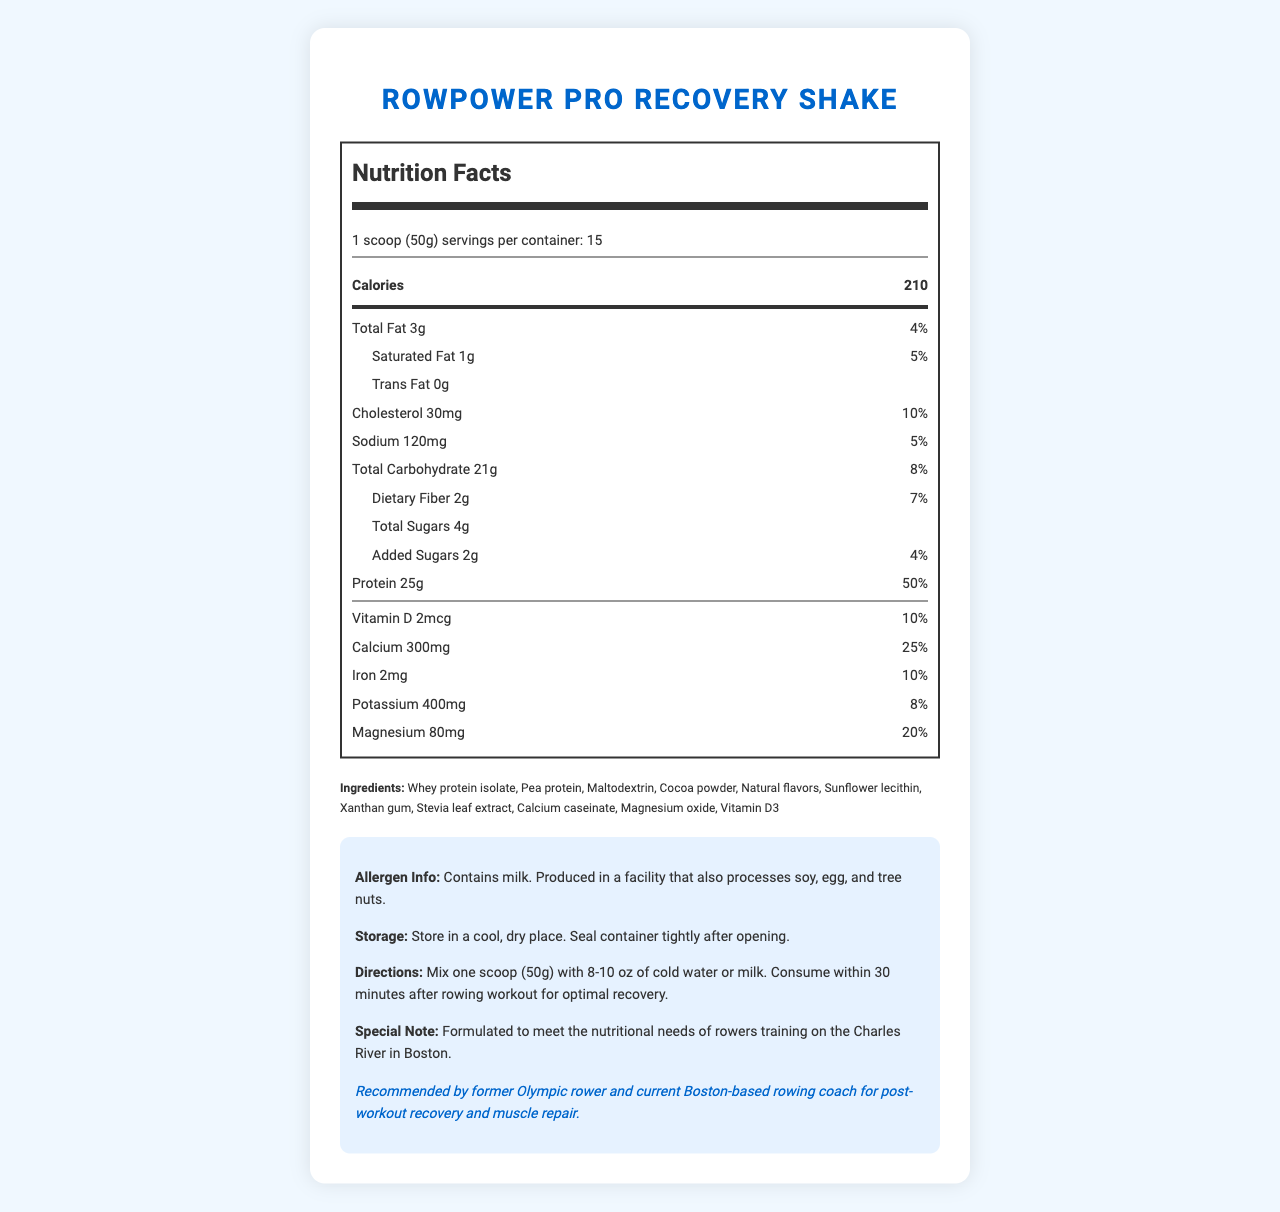Who is the product "RowPower Pro Recovery Shake" recommended by? The coach endorsement section mentions that the product is recommended by a former Olympic rower and current Boston-based rowing coach.
Answer: A former Olympic rower and current Boston-based rowing coach How many calories are there per serving of RowPower Pro Recovery Shake? The nutrition label clearly states that there are 210 calories per serving.
Answer: 210 What is the serving size for this product? The serving size is listed as 1 scoop (50g) in the document.
Answer: 1 scoop (50g) How many servings are there per container? The document specifies that there are 15 servings per container.
Answer: 15 What type of fat content does this product have? The nutrition facts list total fat as 3g, saturated fat as 1g, and trans fat as 0g.
Answer: 3g total fat, 1g saturated fat, 0g trans fat What percentage of the daily value of protein does one serving provide? The document states that one serving provides 25g of protein, which is 50% of the daily value.
Answer: 50% Which vitamin and mineral provides the highest percentage of daily value? A. Vitamin D B. Calcium C. Iron D. Potassium E. Magnesium The document lists calcium as providing 25% of the daily value, which is higher than other listed vitamins and minerals.
Answer: B. Calcium How should one consume RowPower Pro Recovery Shake for optimal recovery? A. Mix one scoop with 16 oz of water before a meal B. Mix one scoop with 8-10 oz of cold water or milk and consume within 30 minutes after a rowing workout C. Mix one scoop with 8-10 oz of warm milk before bedtime The directions section advises users to mix one scoop with 8-10 oz of cold water or milk and consume it within 30 minutes after a rowing workout for optimal recovery.
Answer: B. Mix one scoop with 8-10 oz of cold water or milk and consume within 30 minutes after a rowing workout Is the product safe for someone who is allergic to milk? The allergen information states that the product contains milk.
Answer: No Does this product contain any added sugars? The nutrition facts label indicates that the product contains 2g of added sugars.
Answer: Yes Summarize the main ideas of this document. The document gives a comprehensive overview covering the nutritional content, serving size, number of servings, ingredient list, allergen information, usage directions, and endorsements for the RowPower Pro Recovery Shake.
Answer: The document provides detailed nutrition facts and usage information for the RowPower Pro Recovery Shake, a high-protein shake designed for rowers. The product is endorsed by a former Olympic rower and is suitable for post-workout recovery, containing 210 calories per serving and providing 25g of protein. It also contains several essential vitamins and minerals. Instructions for use and allergen information are included. What is the storage instruction for this product? The storage instructions in the additional information section advise storing the product in a cool, dry place and sealing the container tightly after opening.
Answer: Store in a cool, dry place. Seal container tightly after opening. What carbohydrate components contribute to the total carbohydrate content? The nutrition facts break down the total carbohydrate content into dietary fiber, total sugars, and added sugars.
Answer: Total Carbohydrate 21g, including 2g dietary fiber, 4g total sugars, and 2g added sugars Does the product contain any soy, egg, or tree nuts? The allergen information mentions that the product is produced in a facility that processes soy, egg, and tree nuts but does not confirm if the product itself contains those allergens.
Answer: Cannot be determined 